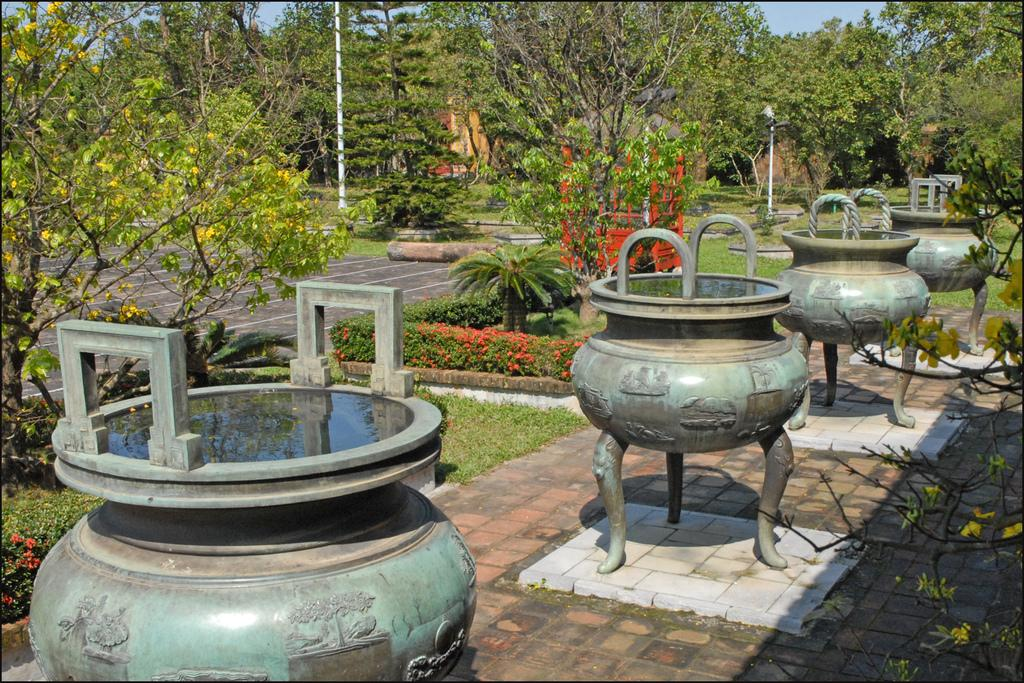What type of structures are present in the image? There are fountains with water in the image. What type of vegetation is visible in the image? There are trees in the image. What other objects can be seen in the image? There are poles in the image. What type of headwear is worn by the people in the image? There are no people visible in the image, only fountains, trees, and poles. What type of battle is taking place in the image? There is no battle present in the image; it features fountains, trees, and poles. 